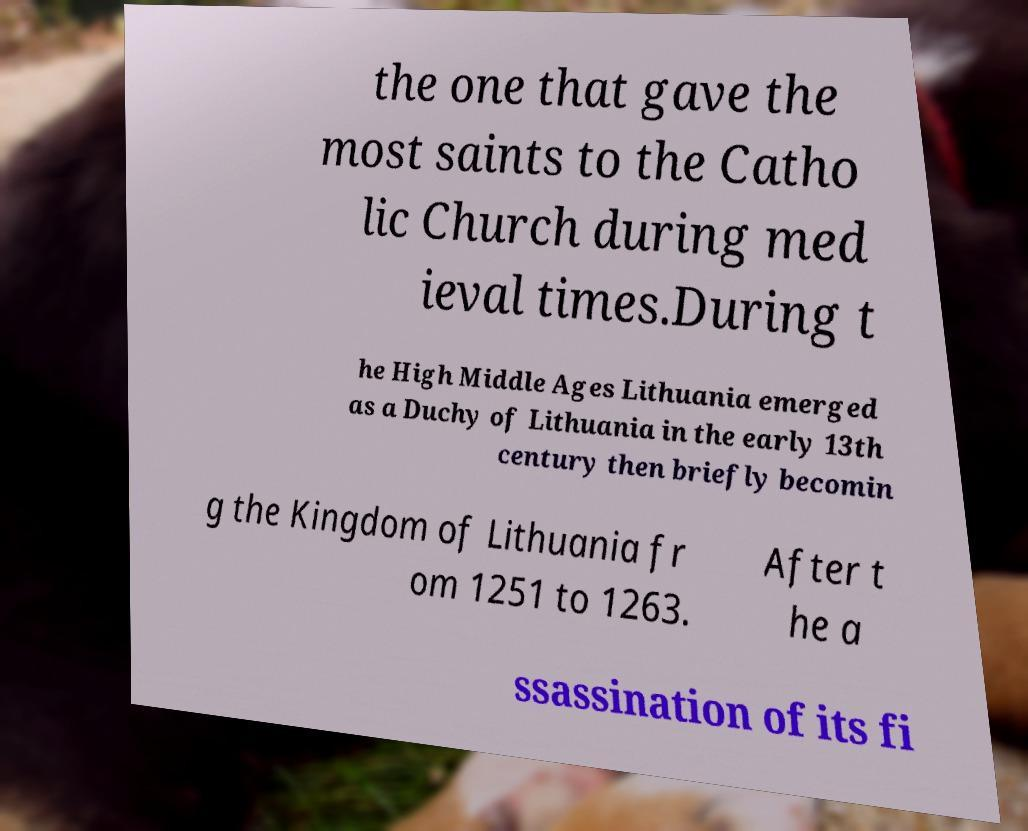There's text embedded in this image that I need extracted. Can you transcribe it verbatim? the one that gave the most saints to the Catho lic Church during med ieval times.During t he High Middle Ages Lithuania emerged as a Duchy of Lithuania in the early 13th century then briefly becomin g the Kingdom of Lithuania fr om 1251 to 1263. After t he a ssassination of its fi 